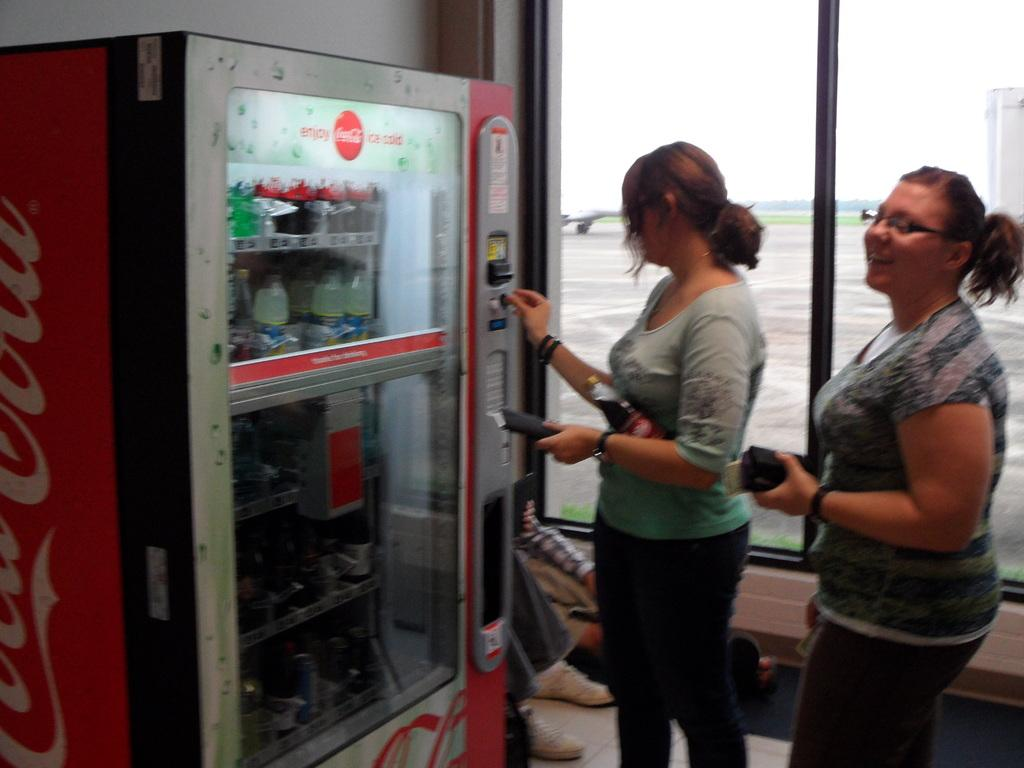<image>
Create a compact narrative representing the image presented. Two women standing at a coca-cola vending machine 